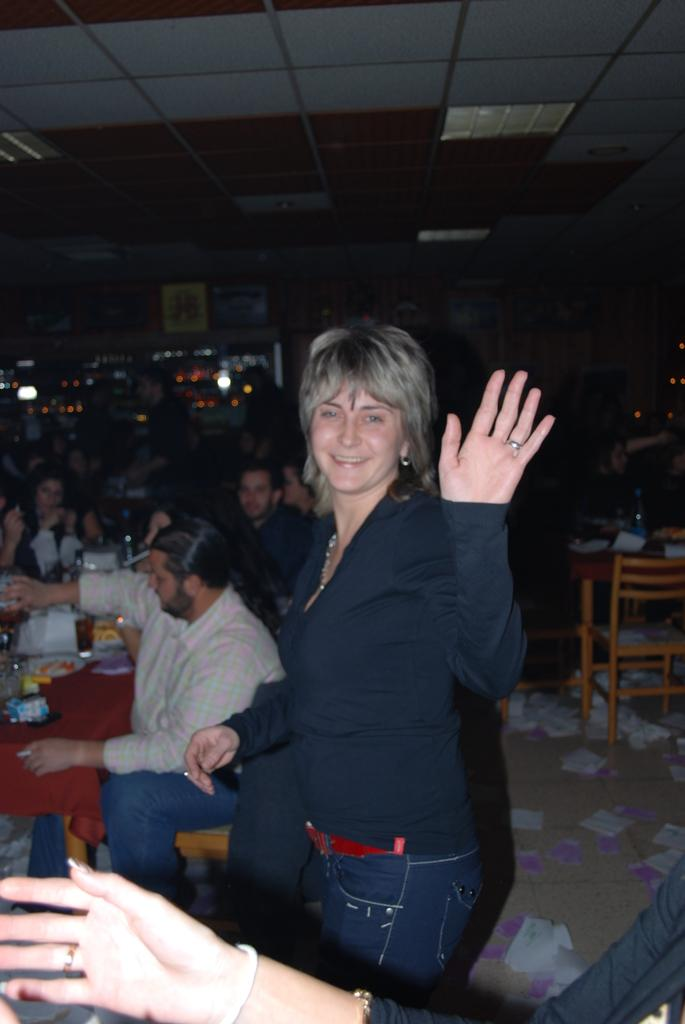How many people are in the image? There is a group of people in the image. What are the people doing in the image? The people are sitting on chairs. What is on the table in the image? There is a glass, bottles, and tissue on the table. Can you describe the woman in the image? There is a woman in the center of the image, and she is standing. What type of mint can be seen growing on the table in the image? There is no mint present on the table in the image. What loss is the woman experiencing in the image? There is no indication of any loss experienced by the woman in the image. 